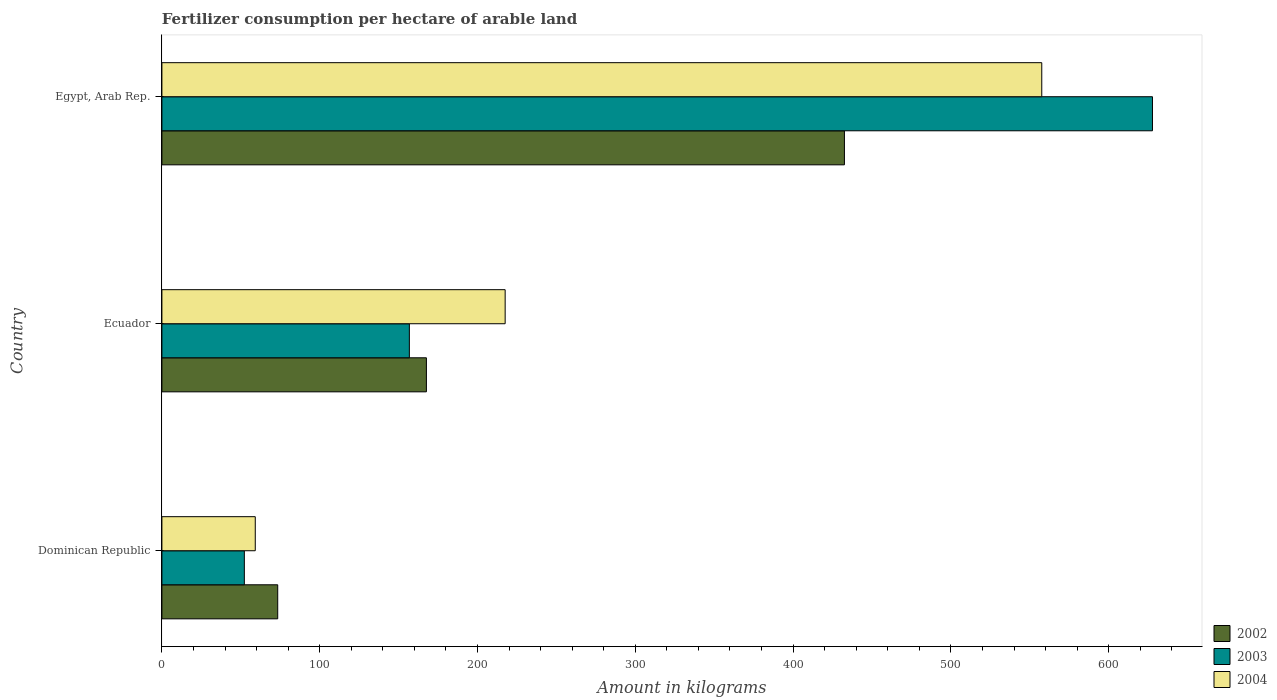Are the number of bars per tick equal to the number of legend labels?
Offer a very short reply. Yes. Are the number of bars on each tick of the Y-axis equal?
Keep it short and to the point. Yes. What is the label of the 3rd group of bars from the top?
Keep it short and to the point. Dominican Republic. What is the amount of fertilizer consumption in 2003 in Dominican Republic?
Make the answer very short. 52.24. Across all countries, what is the maximum amount of fertilizer consumption in 2002?
Ensure brevity in your answer.  432.53. Across all countries, what is the minimum amount of fertilizer consumption in 2003?
Your answer should be compact. 52.24. In which country was the amount of fertilizer consumption in 2004 maximum?
Give a very brief answer. Egypt, Arab Rep. In which country was the amount of fertilizer consumption in 2002 minimum?
Your answer should be compact. Dominican Republic. What is the total amount of fertilizer consumption in 2002 in the graph?
Provide a short and direct response. 673.55. What is the difference between the amount of fertilizer consumption in 2003 in Dominican Republic and that in Ecuador?
Provide a succinct answer. -104.58. What is the difference between the amount of fertilizer consumption in 2004 in Dominican Republic and the amount of fertilizer consumption in 2003 in Ecuador?
Offer a very short reply. -97.65. What is the average amount of fertilizer consumption in 2003 per country?
Give a very brief answer. 278.94. What is the difference between the amount of fertilizer consumption in 2004 and amount of fertilizer consumption in 2003 in Egypt, Arab Rep.?
Offer a terse response. -70.16. What is the ratio of the amount of fertilizer consumption in 2002 in Dominican Republic to that in Ecuador?
Give a very brief answer. 0.44. Is the difference between the amount of fertilizer consumption in 2004 in Dominican Republic and Ecuador greater than the difference between the amount of fertilizer consumption in 2003 in Dominican Republic and Ecuador?
Your answer should be compact. No. What is the difference between the highest and the second highest amount of fertilizer consumption in 2002?
Provide a succinct answer. 264.91. What is the difference between the highest and the lowest amount of fertilizer consumption in 2003?
Provide a short and direct response. 575.51. In how many countries, is the amount of fertilizer consumption in 2003 greater than the average amount of fertilizer consumption in 2003 taken over all countries?
Provide a short and direct response. 1. Is the sum of the amount of fertilizer consumption in 2004 in Ecuador and Egypt, Arab Rep. greater than the maximum amount of fertilizer consumption in 2002 across all countries?
Provide a succinct answer. Yes. Is it the case that in every country, the sum of the amount of fertilizer consumption in 2002 and amount of fertilizer consumption in 2003 is greater than the amount of fertilizer consumption in 2004?
Make the answer very short. Yes. What is the difference between two consecutive major ticks on the X-axis?
Give a very brief answer. 100. Does the graph contain any zero values?
Give a very brief answer. No. How many legend labels are there?
Provide a succinct answer. 3. What is the title of the graph?
Make the answer very short. Fertilizer consumption per hectare of arable land. What is the label or title of the X-axis?
Your response must be concise. Amount in kilograms. What is the label or title of the Y-axis?
Keep it short and to the point. Country. What is the Amount in kilograms in 2002 in Dominican Republic?
Provide a succinct answer. 73.39. What is the Amount in kilograms in 2003 in Dominican Republic?
Offer a very short reply. 52.24. What is the Amount in kilograms in 2004 in Dominican Republic?
Your response must be concise. 59.17. What is the Amount in kilograms of 2002 in Ecuador?
Give a very brief answer. 167.62. What is the Amount in kilograms of 2003 in Ecuador?
Make the answer very short. 156.82. What is the Amount in kilograms in 2004 in Ecuador?
Offer a very short reply. 217.53. What is the Amount in kilograms in 2002 in Egypt, Arab Rep.?
Offer a very short reply. 432.53. What is the Amount in kilograms in 2003 in Egypt, Arab Rep.?
Offer a terse response. 627.75. What is the Amount in kilograms of 2004 in Egypt, Arab Rep.?
Offer a very short reply. 557.59. Across all countries, what is the maximum Amount in kilograms in 2002?
Provide a succinct answer. 432.53. Across all countries, what is the maximum Amount in kilograms of 2003?
Give a very brief answer. 627.75. Across all countries, what is the maximum Amount in kilograms of 2004?
Give a very brief answer. 557.59. Across all countries, what is the minimum Amount in kilograms of 2002?
Your answer should be very brief. 73.39. Across all countries, what is the minimum Amount in kilograms of 2003?
Offer a terse response. 52.24. Across all countries, what is the minimum Amount in kilograms in 2004?
Offer a very short reply. 59.17. What is the total Amount in kilograms of 2002 in the graph?
Provide a succinct answer. 673.55. What is the total Amount in kilograms of 2003 in the graph?
Your answer should be very brief. 836.82. What is the total Amount in kilograms in 2004 in the graph?
Provide a short and direct response. 834.3. What is the difference between the Amount in kilograms of 2002 in Dominican Republic and that in Ecuador?
Your answer should be compact. -94.23. What is the difference between the Amount in kilograms in 2003 in Dominican Republic and that in Ecuador?
Provide a short and direct response. -104.58. What is the difference between the Amount in kilograms in 2004 in Dominican Republic and that in Ecuador?
Provide a short and direct response. -158.36. What is the difference between the Amount in kilograms in 2002 in Dominican Republic and that in Egypt, Arab Rep.?
Offer a terse response. -359.14. What is the difference between the Amount in kilograms in 2003 in Dominican Republic and that in Egypt, Arab Rep.?
Your response must be concise. -575.51. What is the difference between the Amount in kilograms of 2004 in Dominican Republic and that in Egypt, Arab Rep.?
Offer a very short reply. -498.42. What is the difference between the Amount in kilograms of 2002 in Ecuador and that in Egypt, Arab Rep.?
Offer a very short reply. -264.91. What is the difference between the Amount in kilograms of 2003 in Ecuador and that in Egypt, Arab Rep.?
Your answer should be very brief. -470.93. What is the difference between the Amount in kilograms in 2004 in Ecuador and that in Egypt, Arab Rep.?
Keep it short and to the point. -340.06. What is the difference between the Amount in kilograms of 2002 in Dominican Republic and the Amount in kilograms of 2003 in Ecuador?
Your answer should be very brief. -83.43. What is the difference between the Amount in kilograms in 2002 in Dominican Republic and the Amount in kilograms in 2004 in Ecuador?
Provide a succinct answer. -144.14. What is the difference between the Amount in kilograms of 2003 in Dominican Republic and the Amount in kilograms of 2004 in Ecuador?
Make the answer very short. -165.29. What is the difference between the Amount in kilograms in 2002 in Dominican Republic and the Amount in kilograms in 2003 in Egypt, Arab Rep.?
Your response must be concise. -554.36. What is the difference between the Amount in kilograms in 2002 in Dominican Republic and the Amount in kilograms in 2004 in Egypt, Arab Rep.?
Give a very brief answer. -484.2. What is the difference between the Amount in kilograms of 2003 in Dominican Republic and the Amount in kilograms of 2004 in Egypt, Arab Rep.?
Provide a succinct answer. -505.35. What is the difference between the Amount in kilograms in 2002 in Ecuador and the Amount in kilograms in 2003 in Egypt, Arab Rep.?
Your answer should be very brief. -460.13. What is the difference between the Amount in kilograms of 2002 in Ecuador and the Amount in kilograms of 2004 in Egypt, Arab Rep.?
Keep it short and to the point. -389.97. What is the difference between the Amount in kilograms in 2003 in Ecuador and the Amount in kilograms in 2004 in Egypt, Arab Rep.?
Ensure brevity in your answer.  -400.77. What is the average Amount in kilograms in 2002 per country?
Ensure brevity in your answer.  224.52. What is the average Amount in kilograms of 2003 per country?
Your answer should be very brief. 278.94. What is the average Amount in kilograms in 2004 per country?
Your answer should be compact. 278.1. What is the difference between the Amount in kilograms of 2002 and Amount in kilograms of 2003 in Dominican Republic?
Provide a succinct answer. 21.15. What is the difference between the Amount in kilograms in 2002 and Amount in kilograms in 2004 in Dominican Republic?
Give a very brief answer. 14.22. What is the difference between the Amount in kilograms of 2003 and Amount in kilograms of 2004 in Dominican Republic?
Your answer should be very brief. -6.93. What is the difference between the Amount in kilograms of 2002 and Amount in kilograms of 2003 in Ecuador?
Provide a short and direct response. 10.8. What is the difference between the Amount in kilograms of 2002 and Amount in kilograms of 2004 in Ecuador?
Provide a succinct answer. -49.91. What is the difference between the Amount in kilograms of 2003 and Amount in kilograms of 2004 in Ecuador?
Make the answer very short. -60.71. What is the difference between the Amount in kilograms of 2002 and Amount in kilograms of 2003 in Egypt, Arab Rep.?
Your response must be concise. -195.22. What is the difference between the Amount in kilograms in 2002 and Amount in kilograms in 2004 in Egypt, Arab Rep.?
Offer a terse response. -125.06. What is the difference between the Amount in kilograms in 2003 and Amount in kilograms in 2004 in Egypt, Arab Rep.?
Give a very brief answer. 70.16. What is the ratio of the Amount in kilograms in 2002 in Dominican Republic to that in Ecuador?
Provide a short and direct response. 0.44. What is the ratio of the Amount in kilograms in 2003 in Dominican Republic to that in Ecuador?
Give a very brief answer. 0.33. What is the ratio of the Amount in kilograms of 2004 in Dominican Republic to that in Ecuador?
Your response must be concise. 0.27. What is the ratio of the Amount in kilograms of 2002 in Dominican Republic to that in Egypt, Arab Rep.?
Ensure brevity in your answer.  0.17. What is the ratio of the Amount in kilograms in 2003 in Dominican Republic to that in Egypt, Arab Rep.?
Your response must be concise. 0.08. What is the ratio of the Amount in kilograms of 2004 in Dominican Republic to that in Egypt, Arab Rep.?
Offer a terse response. 0.11. What is the ratio of the Amount in kilograms of 2002 in Ecuador to that in Egypt, Arab Rep.?
Offer a terse response. 0.39. What is the ratio of the Amount in kilograms in 2003 in Ecuador to that in Egypt, Arab Rep.?
Your response must be concise. 0.25. What is the ratio of the Amount in kilograms of 2004 in Ecuador to that in Egypt, Arab Rep.?
Offer a very short reply. 0.39. What is the difference between the highest and the second highest Amount in kilograms of 2002?
Your answer should be compact. 264.91. What is the difference between the highest and the second highest Amount in kilograms in 2003?
Your answer should be very brief. 470.93. What is the difference between the highest and the second highest Amount in kilograms in 2004?
Keep it short and to the point. 340.06. What is the difference between the highest and the lowest Amount in kilograms of 2002?
Ensure brevity in your answer.  359.14. What is the difference between the highest and the lowest Amount in kilograms in 2003?
Offer a terse response. 575.51. What is the difference between the highest and the lowest Amount in kilograms in 2004?
Give a very brief answer. 498.42. 